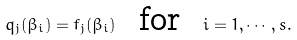Convert formula to latex. <formula><loc_0><loc_0><loc_500><loc_500>q _ { j } ( \beta _ { i } ) = f _ { j } ( \beta _ { i } ) \ \text { for } \ i = 1 , \cdots , s .</formula> 